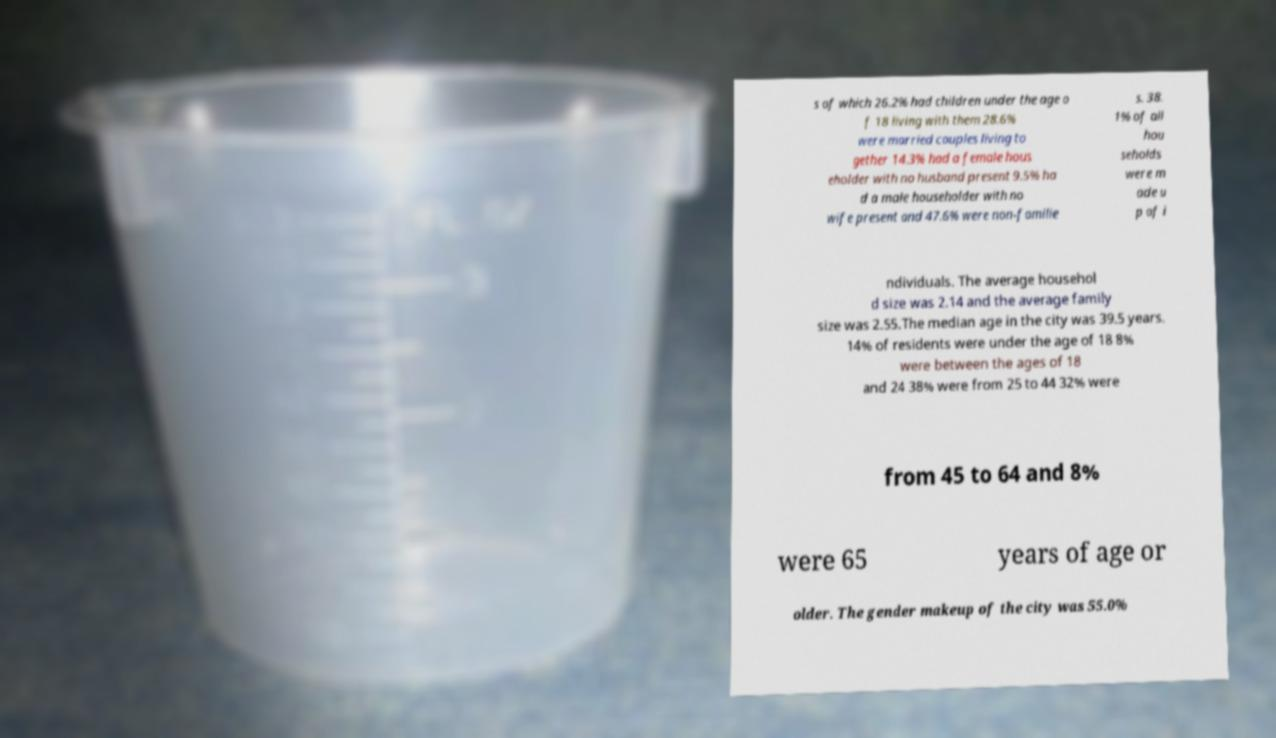Please read and relay the text visible in this image. What does it say? s of which 26.2% had children under the age o f 18 living with them 28.6% were married couples living to gether 14.3% had a female hous eholder with no husband present 9.5% ha d a male householder with no wife present and 47.6% were non-familie s. 38. 1% of all hou seholds were m ade u p of i ndividuals. The average househol d size was 2.14 and the average family size was 2.55.The median age in the city was 39.5 years. 14% of residents were under the age of 18 8% were between the ages of 18 and 24 38% were from 25 to 44 32% were from 45 to 64 and 8% were 65 years of age or older. The gender makeup of the city was 55.0% 